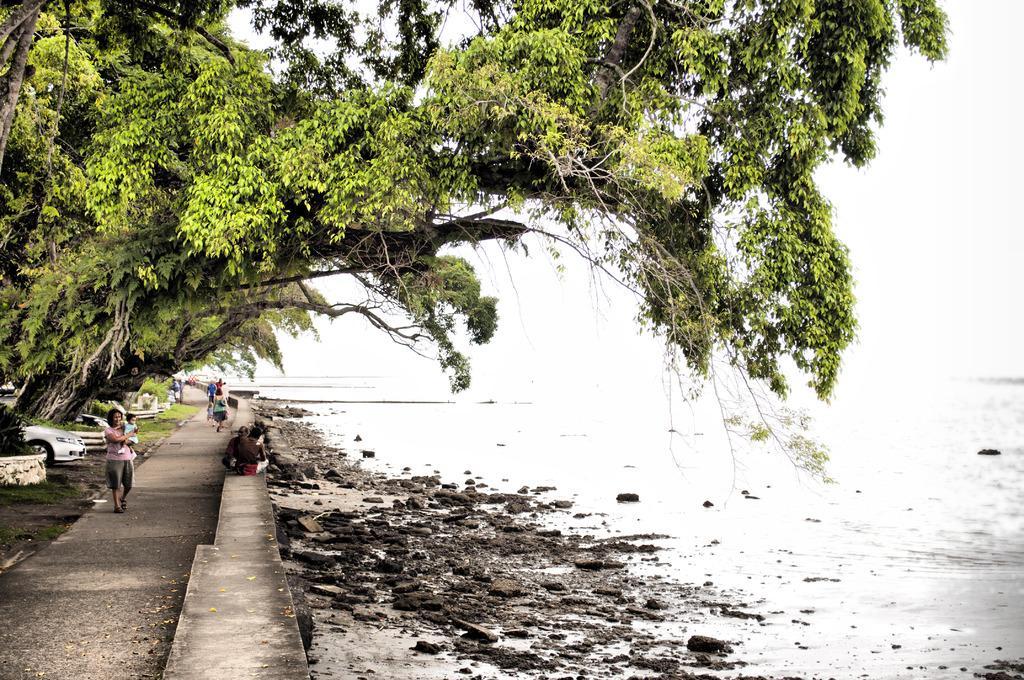Please provide a concise description of this image. On the left side, there are persons walking on the road, near a wall, on which, there are persons who are sitting. Beside this road, there are vehicles parked, near trees. On the right side, there is a water and sky. 